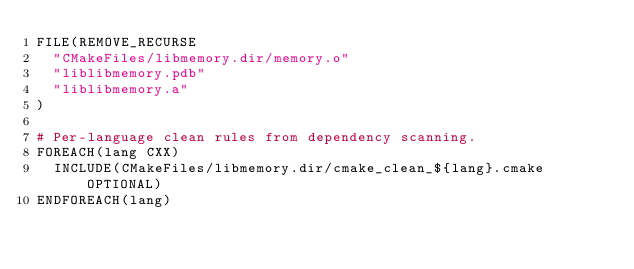<code> <loc_0><loc_0><loc_500><loc_500><_CMake_>FILE(REMOVE_RECURSE
  "CMakeFiles/libmemory.dir/memory.o"
  "liblibmemory.pdb"
  "liblibmemory.a"
)

# Per-language clean rules from dependency scanning.
FOREACH(lang CXX)
  INCLUDE(CMakeFiles/libmemory.dir/cmake_clean_${lang}.cmake OPTIONAL)
ENDFOREACH(lang)
</code> 